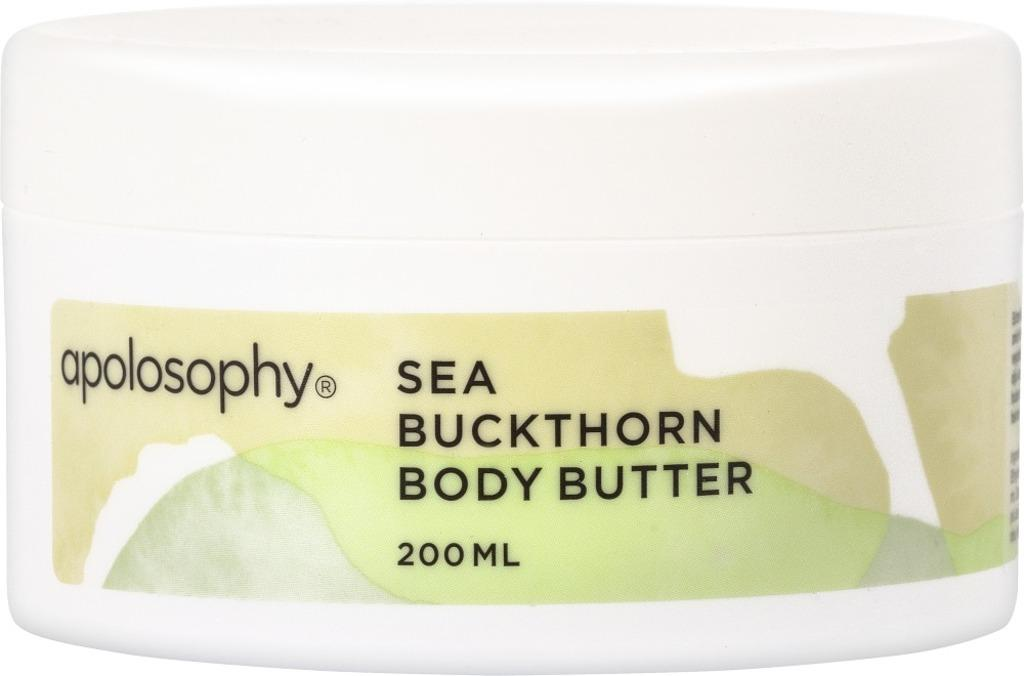<image>
Write a terse but informative summary of the picture. White package with green label 200ml body butter. 